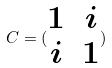Convert formula to latex. <formula><loc_0><loc_0><loc_500><loc_500>C = ( \begin{matrix} 1 & i \\ i & 1 \end{matrix} )</formula> 